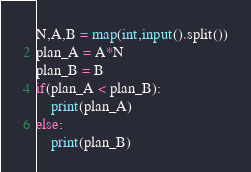Convert code to text. <code><loc_0><loc_0><loc_500><loc_500><_Python_>N,A,B = map(int,input().split())
plan_A = A*N
plan_B = B
if(plan_A < plan_B):
    print(plan_A)
else:
    print(plan_B)</code> 